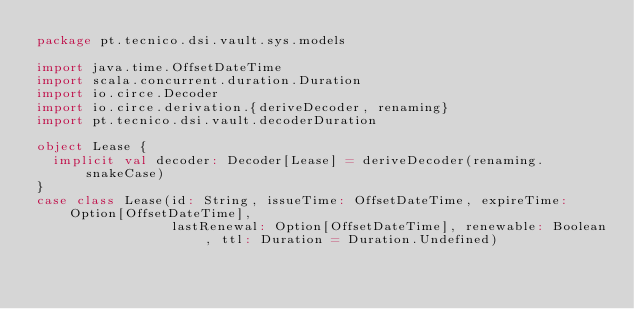<code> <loc_0><loc_0><loc_500><loc_500><_Scala_>package pt.tecnico.dsi.vault.sys.models

import java.time.OffsetDateTime
import scala.concurrent.duration.Duration
import io.circe.Decoder
import io.circe.derivation.{deriveDecoder, renaming}
import pt.tecnico.dsi.vault.decoderDuration

object Lease {
  implicit val decoder: Decoder[Lease] = deriveDecoder(renaming.snakeCase)
}
case class Lease(id: String, issueTime: OffsetDateTime, expireTime: Option[OffsetDateTime],
                 lastRenewal: Option[OffsetDateTime], renewable: Boolean, ttl: Duration = Duration.Undefined)</code> 